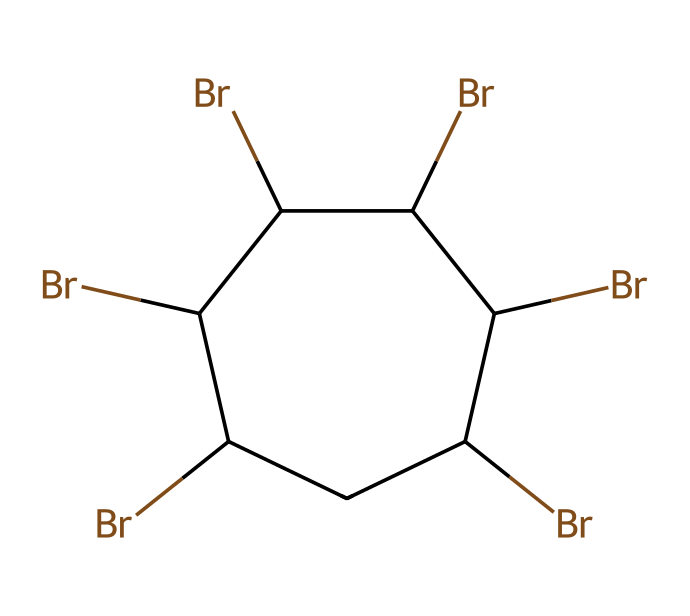How many bromine atoms are present in the structure? The SMILES representation indicates the presence of bromine atoms, specifically counting the instances of "Br". There are six occurrences of "Br" in the SMILES code.
Answer: six What type of ring structure does this chemical have? The structure is a cyclic compound as indicated by "C1" and "C1" at the beginning and end, which denote the start and end of a ring, with all carbon atoms in a closed loop.
Answer: cyclic What is the chemical's overall classification? This chemical belongs to the category of halogenated hydrocarbons due to the presence of multiple bromine atoms substituting the hydrogen in a carbon framework.
Answer: halogenated hydrocarbon How many carbon atoms are in this molecule? The SMILES notation shows "C", and counting those present in the cyclic structure reveals a total of six carbon atoms.
Answer: six What is the significance of bromine in flame retardance? Bromine is known for its flame-retardant properties, which help in preventing ignition or slowing down the combustion process in materials like football uniforms.
Answer: flame retardant What bond type predominates in this structure? The structure consists of carbon-carbon single bonds and carbon-bromine single bonds, which are both covalent bonds. The presence of saturated carbon atoms indicates no double or triple bonds.
Answer: covalent What would happen if the bromine atoms were replaced with chlorine? Replacing bromine with chlorine would change the chemical's properties, as chlorine is less effective as a flame retardant compared to bromine due to its higher reactivity and different molecular interactions.
Answer: change in properties 